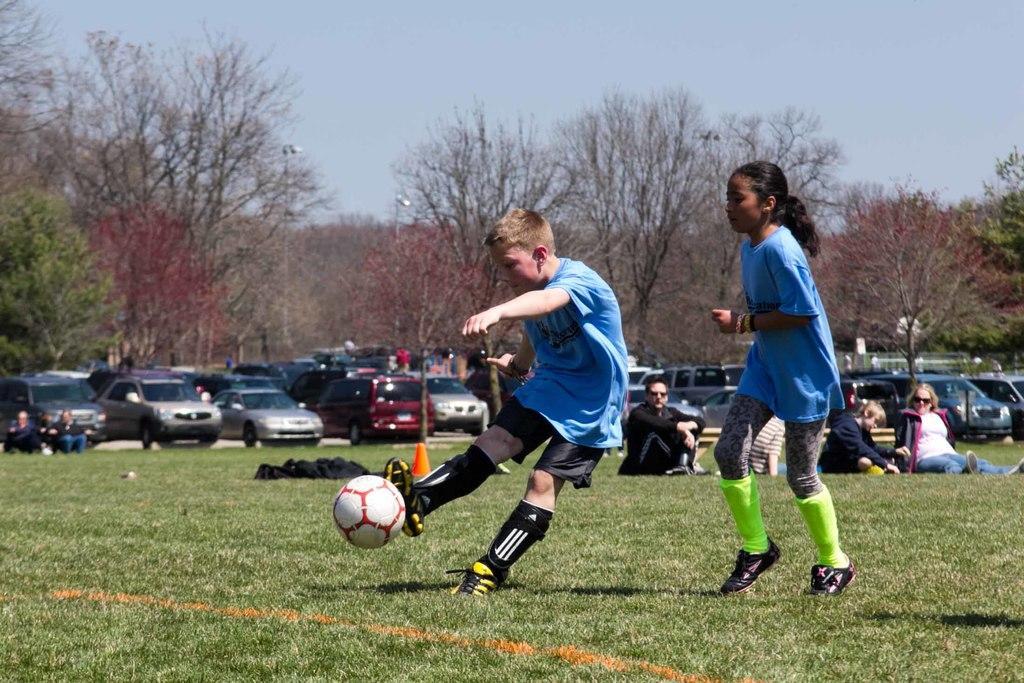Describe this image in one or two sentences. In the center we can see two players and on the left we can see ball. And coming to back ground we can see trees,sky,vehicles and few persons were sitting on the grass. 